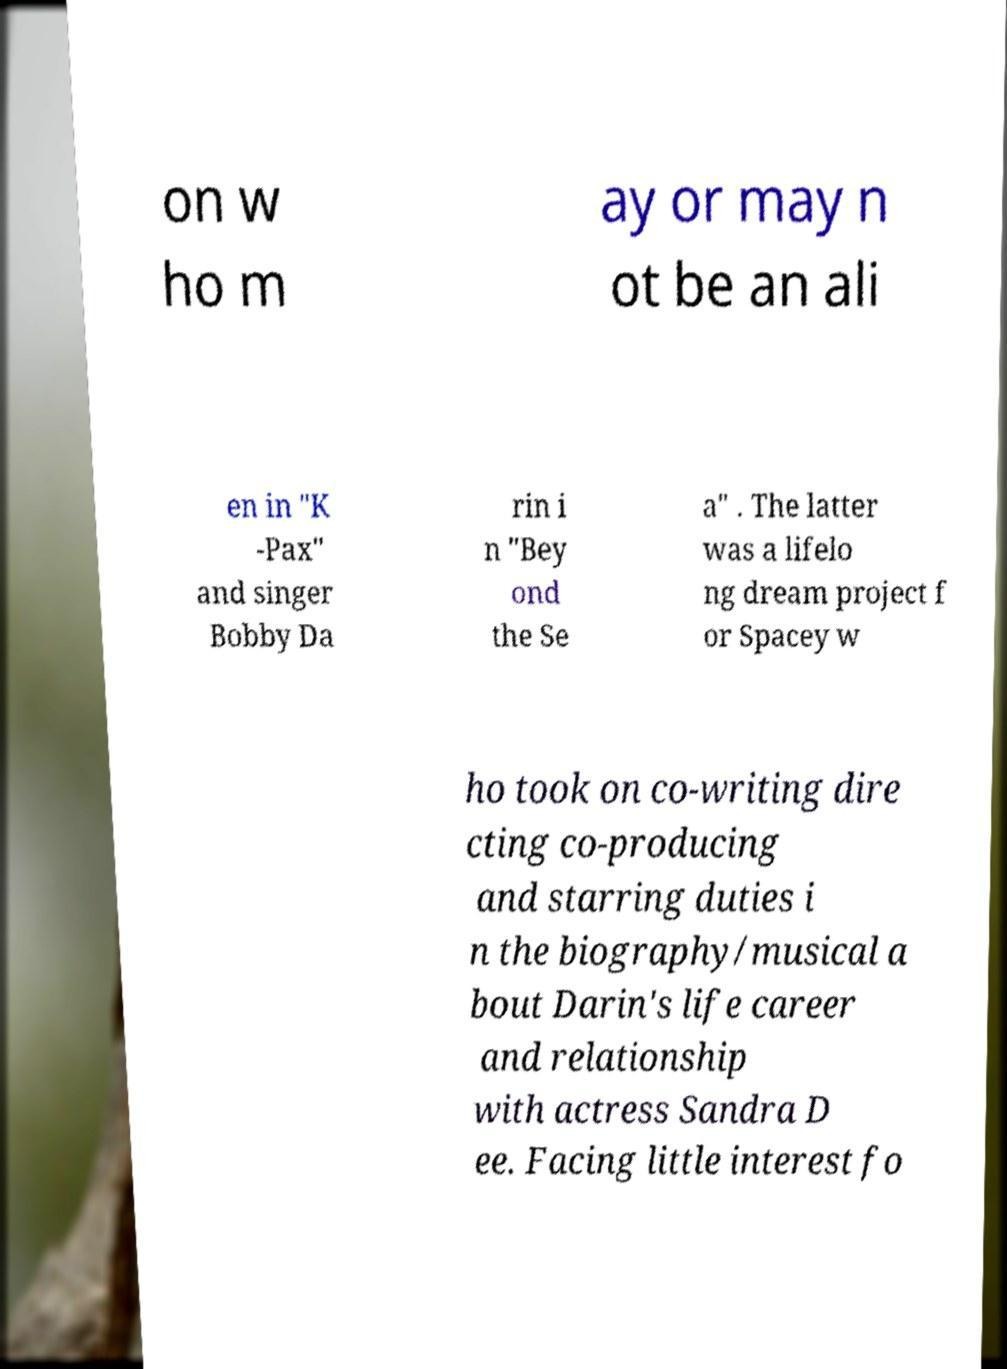Please identify and transcribe the text found in this image. on w ho m ay or may n ot be an ali en in "K -Pax" and singer Bobby Da rin i n "Bey ond the Se a" . The latter was a lifelo ng dream project f or Spacey w ho took on co-writing dire cting co-producing and starring duties i n the biography/musical a bout Darin's life career and relationship with actress Sandra D ee. Facing little interest fo 